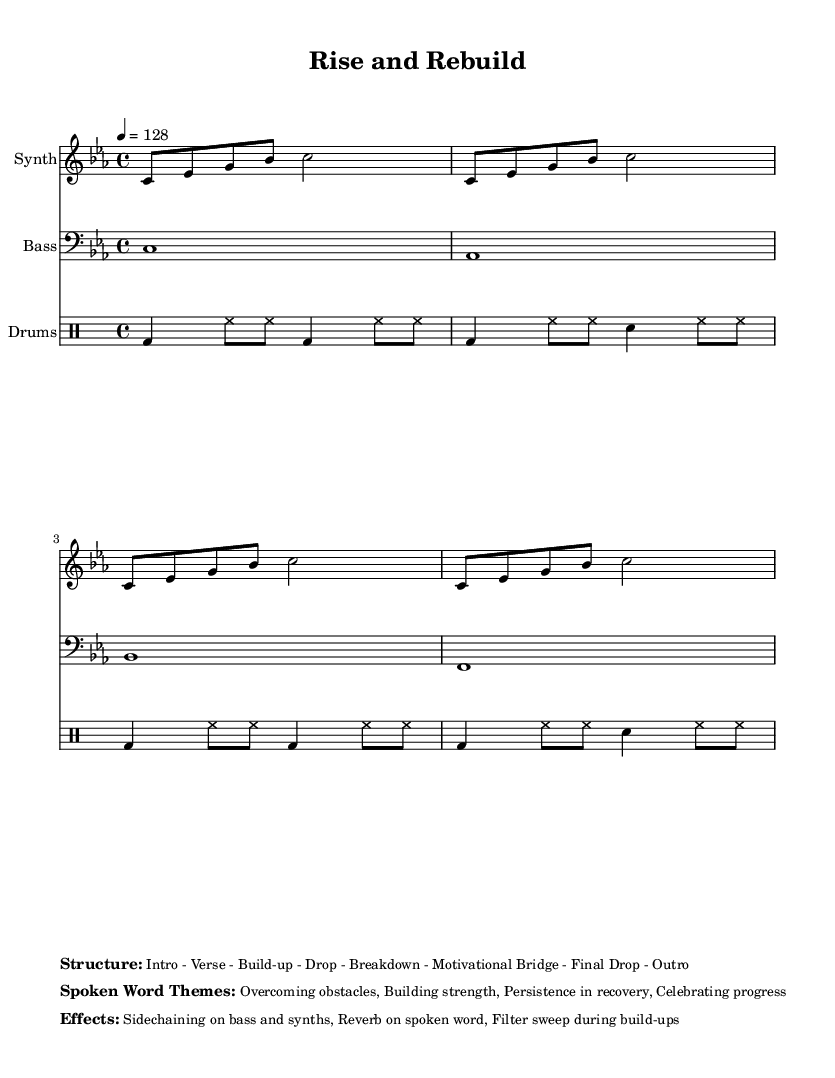What is the key signature of this music? The key signature is C minor, which has three flats (B♭, E♭, A♭).
Answer: C minor What is the time signature of this music? The time signature is written as 4/4, which means there are four beats per measure and a quarter note receives one beat.
Answer: 4/4 What is the tempo marking of this piece? The tempo marking is specified as quarter note equals 128 beats per minute, indicating a relatively fast tempo.
Answer: 128 How many sections are in the structure of this piece? The structure consists of eight sections: Intro, Verse, Build-up, Drop, Breakdown, Motivational Bridge, Final Drop, and Outro.
Answer: 8 What themes are addressed in the spoken word section? The spoken word themes focus on overcoming obstacles, building strength, persistence in recovery, and celebrating progress.
Answer: Overcoming obstacles, Building strength, Persistence in recovery, Celebrating progress What musical effect is used on the bass and synths? The effect used on the bass and synths is sidechaining, which gives a pumping sound characteristic of electronic music.
Answer: Sidechaining What role do drums play in this electronic piece? The drums provide the rhythmic foundation and drive the energy in this electronic music, essential for rehabilitation exercises.
Answer: Rhythmic foundation 